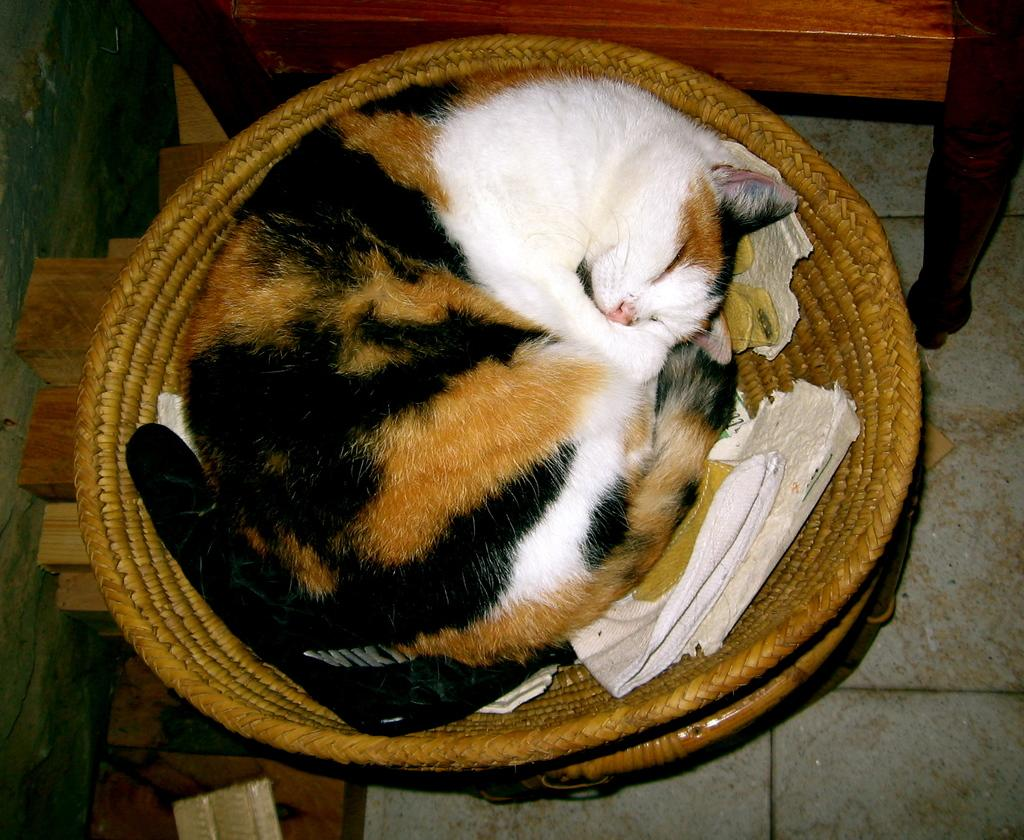What type of animal can be seen in the image? There is a cat in the image. What is the cat doing in the image? The cat is sleeping in a basket. Where is the basket located in the image? The basket is on the floor. What type of furniture is visible in the image? There is a wooden chair in the image. How is the wooden chair positioned in the image? The wooden chair is at the top of the image. What type of tray is being used by the coach in the image? There is no coach or tray present in the image; it features a cat sleeping in a basket on the floor and a wooden chair at the top of the image. 